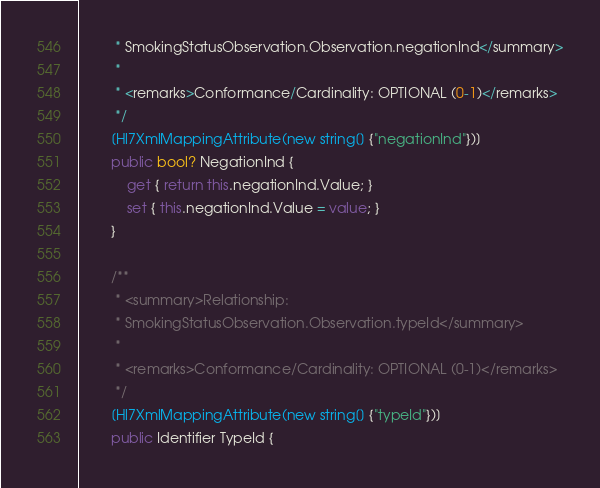Convert code to text. <code><loc_0><loc_0><loc_500><loc_500><_C#_>         * SmokingStatusObservation.Observation.negationInd</summary>
         * 
         * <remarks>Conformance/Cardinality: OPTIONAL (0-1)</remarks>
         */
        [Hl7XmlMappingAttribute(new string[] {"negationInd"})]
        public bool? NegationInd {
            get { return this.negationInd.Value; }
            set { this.negationInd.Value = value; }
        }

        /**
         * <summary>Relationship: 
         * SmokingStatusObservation.Observation.typeId</summary>
         * 
         * <remarks>Conformance/Cardinality: OPTIONAL (0-1)</remarks>
         */
        [Hl7XmlMappingAttribute(new string[] {"typeId"})]
        public Identifier TypeId {</code> 